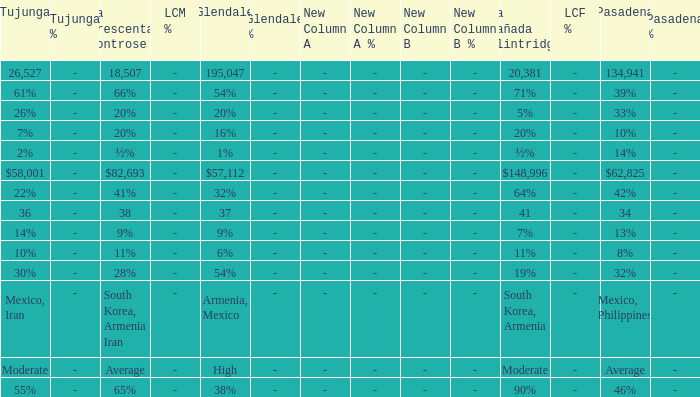What is the proportion of glendale when pasadena is 14%? 1%. 